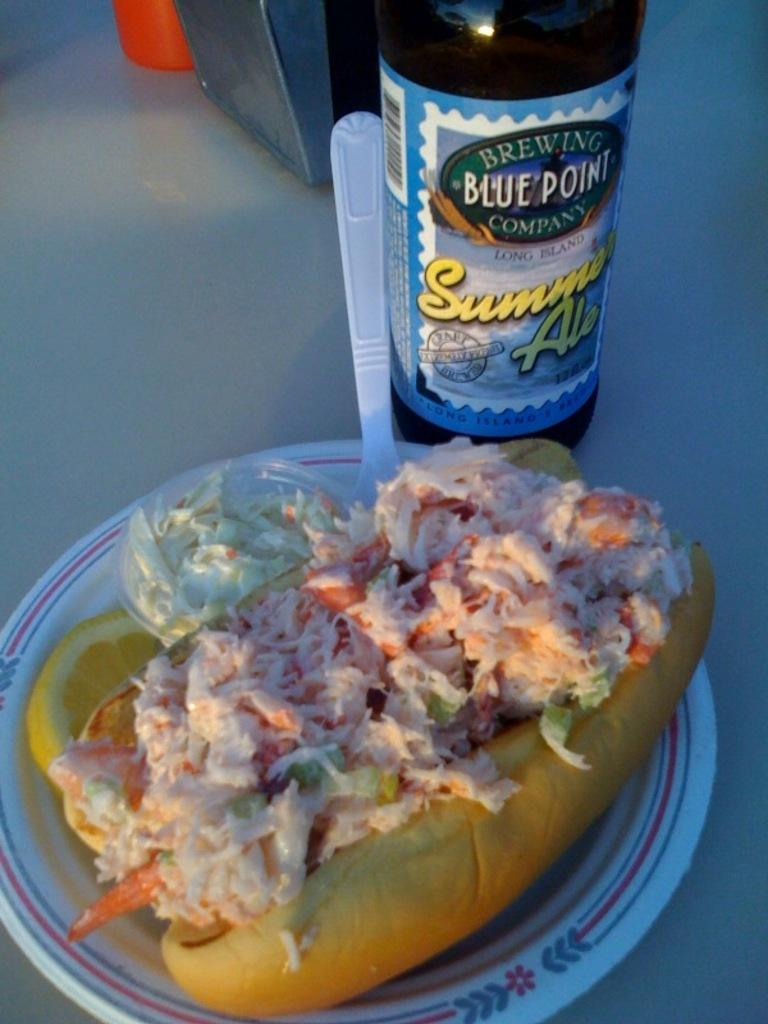<image>
Offer a succinct explanation of the picture presented. A bottle of Summer Ale from Blue Point Brewing Company is on a table next to a plate of food. 